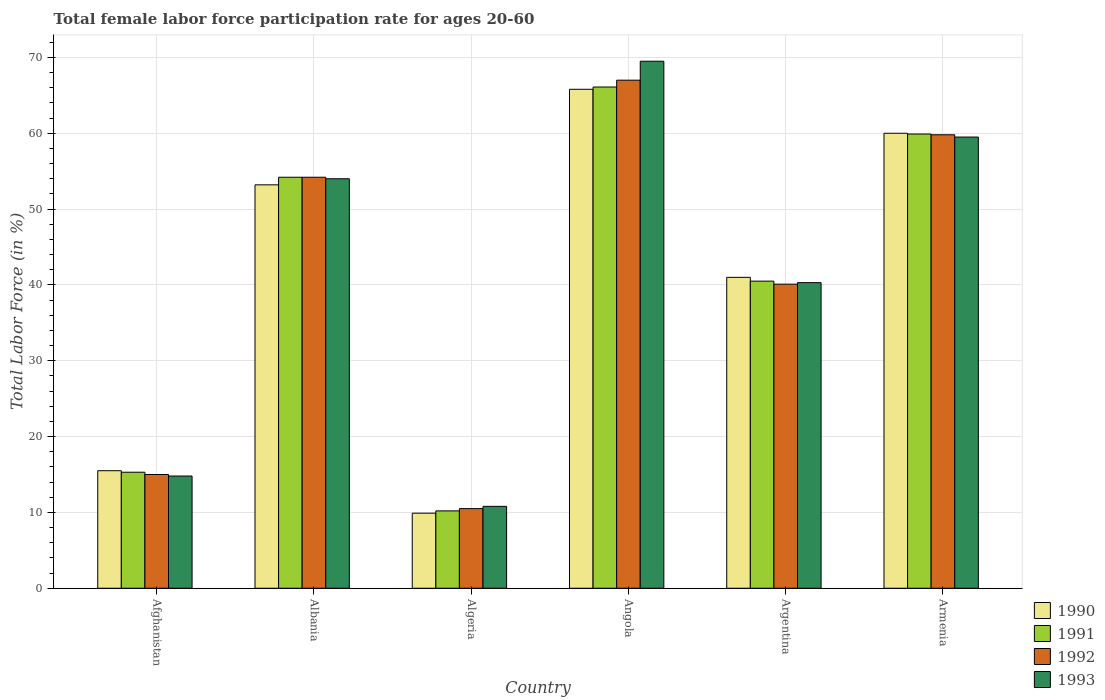How many groups of bars are there?
Your answer should be very brief. 6. How many bars are there on the 2nd tick from the left?
Ensure brevity in your answer.  4. How many bars are there on the 6th tick from the right?
Provide a short and direct response. 4. What is the label of the 4th group of bars from the left?
Keep it short and to the point. Angola. What is the female labor force participation rate in 1992 in Afghanistan?
Offer a very short reply. 15. Across all countries, what is the maximum female labor force participation rate in 1993?
Your answer should be compact. 69.5. Across all countries, what is the minimum female labor force participation rate in 1993?
Offer a very short reply. 10.8. In which country was the female labor force participation rate in 1990 maximum?
Your response must be concise. Angola. In which country was the female labor force participation rate in 1992 minimum?
Make the answer very short. Algeria. What is the total female labor force participation rate in 1990 in the graph?
Ensure brevity in your answer.  245.4. What is the difference between the female labor force participation rate in 1991 in Albania and that in Armenia?
Ensure brevity in your answer.  -5.7. What is the difference between the female labor force participation rate in 1990 in Angola and the female labor force participation rate in 1991 in Albania?
Provide a succinct answer. 11.6. What is the average female labor force participation rate in 1992 per country?
Make the answer very short. 41.1. What is the difference between the female labor force participation rate of/in 1993 and female labor force participation rate of/in 1991 in Albania?
Give a very brief answer. -0.2. In how many countries, is the female labor force participation rate in 1993 greater than 50 %?
Keep it short and to the point. 3. What is the ratio of the female labor force participation rate in 1992 in Albania to that in Armenia?
Offer a terse response. 0.91. Is the difference between the female labor force participation rate in 1993 in Angola and Armenia greater than the difference between the female labor force participation rate in 1991 in Angola and Armenia?
Offer a very short reply. Yes. What is the difference between the highest and the second highest female labor force participation rate in 1991?
Offer a terse response. 6.2. What is the difference between the highest and the lowest female labor force participation rate in 1993?
Your answer should be very brief. 58.7. In how many countries, is the female labor force participation rate in 1992 greater than the average female labor force participation rate in 1992 taken over all countries?
Offer a very short reply. 3. Is the sum of the female labor force participation rate in 1991 in Albania and Argentina greater than the maximum female labor force participation rate in 1990 across all countries?
Your response must be concise. Yes. Is it the case that in every country, the sum of the female labor force participation rate in 1991 and female labor force participation rate in 1992 is greater than the sum of female labor force participation rate in 1993 and female labor force participation rate in 1990?
Offer a terse response. No. What does the 1st bar from the left in Armenia represents?
Provide a short and direct response. 1990. Is it the case that in every country, the sum of the female labor force participation rate in 1991 and female labor force participation rate in 1993 is greater than the female labor force participation rate in 1990?
Your answer should be very brief. Yes. Does the graph contain grids?
Your response must be concise. Yes. Where does the legend appear in the graph?
Offer a very short reply. Bottom right. How many legend labels are there?
Your response must be concise. 4. What is the title of the graph?
Make the answer very short. Total female labor force participation rate for ages 20-60. What is the label or title of the X-axis?
Make the answer very short. Country. What is the Total Labor Force (in %) of 1991 in Afghanistan?
Your answer should be very brief. 15.3. What is the Total Labor Force (in %) in 1992 in Afghanistan?
Ensure brevity in your answer.  15. What is the Total Labor Force (in %) of 1993 in Afghanistan?
Offer a very short reply. 14.8. What is the Total Labor Force (in %) in 1990 in Albania?
Ensure brevity in your answer.  53.2. What is the Total Labor Force (in %) in 1991 in Albania?
Provide a succinct answer. 54.2. What is the Total Labor Force (in %) of 1992 in Albania?
Make the answer very short. 54.2. What is the Total Labor Force (in %) in 1993 in Albania?
Offer a terse response. 54. What is the Total Labor Force (in %) in 1990 in Algeria?
Ensure brevity in your answer.  9.9. What is the Total Labor Force (in %) of 1991 in Algeria?
Offer a terse response. 10.2. What is the Total Labor Force (in %) in 1993 in Algeria?
Your response must be concise. 10.8. What is the Total Labor Force (in %) of 1990 in Angola?
Keep it short and to the point. 65.8. What is the Total Labor Force (in %) of 1991 in Angola?
Offer a very short reply. 66.1. What is the Total Labor Force (in %) of 1993 in Angola?
Offer a very short reply. 69.5. What is the Total Labor Force (in %) of 1990 in Argentina?
Keep it short and to the point. 41. What is the Total Labor Force (in %) of 1991 in Argentina?
Give a very brief answer. 40.5. What is the Total Labor Force (in %) in 1992 in Argentina?
Offer a terse response. 40.1. What is the Total Labor Force (in %) of 1993 in Argentina?
Make the answer very short. 40.3. What is the Total Labor Force (in %) of 1991 in Armenia?
Give a very brief answer. 59.9. What is the Total Labor Force (in %) in 1992 in Armenia?
Provide a succinct answer. 59.8. What is the Total Labor Force (in %) in 1993 in Armenia?
Provide a short and direct response. 59.5. Across all countries, what is the maximum Total Labor Force (in %) in 1990?
Your response must be concise. 65.8. Across all countries, what is the maximum Total Labor Force (in %) of 1991?
Give a very brief answer. 66.1. Across all countries, what is the maximum Total Labor Force (in %) of 1992?
Provide a succinct answer. 67. Across all countries, what is the maximum Total Labor Force (in %) of 1993?
Your answer should be very brief. 69.5. Across all countries, what is the minimum Total Labor Force (in %) in 1990?
Keep it short and to the point. 9.9. Across all countries, what is the minimum Total Labor Force (in %) in 1991?
Your answer should be compact. 10.2. Across all countries, what is the minimum Total Labor Force (in %) in 1992?
Give a very brief answer. 10.5. Across all countries, what is the minimum Total Labor Force (in %) in 1993?
Give a very brief answer. 10.8. What is the total Total Labor Force (in %) in 1990 in the graph?
Give a very brief answer. 245.4. What is the total Total Labor Force (in %) in 1991 in the graph?
Make the answer very short. 246.2. What is the total Total Labor Force (in %) of 1992 in the graph?
Make the answer very short. 246.6. What is the total Total Labor Force (in %) of 1993 in the graph?
Keep it short and to the point. 248.9. What is the difference between the Total Labor Force (in %) in 1990 in Afghanistan and that in Albania?
Offer a terse response. -37.7. What is the difference between the Total Labor Force (in %) in 1991 in Afghanistan and that in Albania?
Your response must be concise. -38.9. What is the difference between the Total Labor Force (in %) in 1992 in Afghanistan and that in Albania?
Keep it short and to the point. -39.2. What is the difference between the Total Labor Force (in %) of 1993 in Afghanistan and that in Albania?
Offer a terse response. -39.2. What is the difference between the Total Labor Force (in %) in 1991 in Afghanistan and that in Algeria?
Offer a terse response. 5.1. What is the difference between the Total Labor Force (in %) in 1992 in Afghanistan and that in Algeria?
Keep it short and to the point. 4.5. What is the difference between the Total Labor Force (in %) in 1990 in Afghanistan and that in Angola?
Provide a succinct answer. -50.3. What is the difference between the Total Labor Force (in %) in 1991 in Afghanistan and that in Angola?
Offer a very short reply. -50.8. What is the difference between the Total Labor Force (in %) of 1992 in Afghanistan and that in Angola?
Your answer should be very brief. -52. What is the difference between the Total Labor Force (in %) of 1993 in Afghanistan and that in Angola?
Give a very brief answer. -54.7. What is the difference between the Total Labor Force (in %) of 1990 in Afghanistan and that in Argentina?
Provide a succinct answer. -25.5. What is the difference between the Total Labor Force (in %) of 1991 in Afghanistan and that in Argentina?
Offer a very short reply. -25.2. What is the difference between the Total Labor Force (in %) of 1992 in Afghanistan and that in Argentina?
Give a very brief answer. -25.1. What is the difference between the Total Labor Force (in %) of 1993 in Afghanistan and that in Argentina?
Offer a very short reply. -25.5. What is the difference between the Total Labor Force (in %) of 1990 in Afghanistan and that in Armenia?
Keep it short and to the point. -44.5. What is the difference between the Total Labor Force (in %) of 1991 in Afghanistan and that in Armenia?
Make the answer very short. -44.6. What is the difference between the Total Labor Force (in %) in 1992 in Afghanistan and that in Armenia?
Give a very brief answer. -44.8. What is the difference between the Total Labor Force (in %) in 1993 in Afghanistan and that in Armenia?
Your answer should be compact. -44.7. What is the difference between the Total Labor Force (in %) of 1990 in Albania and that in Algeria?
Provide a succinct answer. 43.3. What is the difference between the Total Labor Force (in %) in 1991 in Albania and that in Algeria?
Offer a very short reply. 44. What is the difference between the Total Labor Force (in %) in 1992 in Albania and that in Algeria?
Give a very brief answer. 43.7. What is the difference between the Total Labor Force (in %) of 1993 in Albania and that in Algeria?
Offer a very short reply. 43.2. What is the difference between the Total Labor Force (in %) in 1993 in Albania and that in Angola?
Offer a terse response. -15.5. What is the difference between the Total Labor Force (in %) in 1992 in Albania and that in Argentina?
Your answer should be very brief. 14.1. What is the difference between the Total Labor Force (in %) in 1993 in Albania and that in Argentina?
Your answer should be very brief. 13.7. What is the difference between the Total Labor Force (in %) of 1990 in Albania and that in Armenia?
Offer a very short reply. -6.8. What is the difference between the Total Labor Force (in %) in 1992 in Albania and that in Armenia?
Provide a short and direct response. -5.6. What is the difference between the Total Labor Force (in %) in 1993 in Albania and that in Armenia?
Offer a very short reply. -5.5. What is the difference between the Total Labor Force (in %) in 1990 in Algeria and that in Angola?
Offer a terse response. -55.9. What is the difference between the Total Labor Force (in %) of 1991 in Algeria and that in Angola?
Keep it short and to the point. -55.9. What is the difference between the Total Labor Force (in %) of 1992 in Algeria and that in Angola?
Your answer should be very brief. -56.5. What is the difference between the Total Labor Force (in %) in 1993 in Algeria and that in Angola?
Provide a succinct answer. -58.7. What is the difference between the Total Labor Force (in %) in 1990 in Algeria and that in Argentina?
Offer a terse response. -31.1. What is the difference between the Total Labor Force (in %) of 1991 in Algeria and that in Argentina?
Give a very brief answer. -30.3. What is the difference between the Total Labor Force (in %) in 1992 in Algeria and that in Argentina?
Offer a terse response. -29.6. What is the difference between the Total Labor Force (in %) in 1993 in Algeria and that in Argentina?
Offer a very short reply. -29.5. What is the difference between the Total Labor Force (in %) in 1990 in Algeria and that in Armenia?
Your answer should be compact. -50.1. What is the difference between the Total Labor Force (in %) of 1991 in Algeria and that in Armenia?
Your answer should be very brief. -49.7. What is the difference between the Total Labor Force (in %) in 1992 in Algeria and that in Armenia?
Give a very brief answer. -49.3. What is the difference between the Total Labor Force (in %) in 1993 in Algeria and that in Armenia?
Offer a terse response. -48.7. What is the difference between the Total Labor Force (in %) in 1990 in Angola and that in Argentina?
Offer a terse response. 24.8. What is the difference between the Total Labor Force (in %) in 1991 in Angola and that in Argentina?
Your answer should be compact. 25.6. What is the difference between the Total Labor Force (in %) of 1992 in Angola and that in Argentina?
Keep it short and to the point. 26.9. What is the difference between the Total Labor Force (in %) of 1993 in Angola and that in Argentina?
Offer a very short reply. 29.2. What is the difference between the Total Labor Force (in %) in 1993 in Angola and that in Armenia?
Your answer should be compact. 10. What is the difference between the Total Labor Force (in %) in 1990 in Argentina and that in Armenia?
Make the answer very short. -19. What is the difference between the Total Labor Force (in %) in 1991 in Argentina and that in Armenia?
Keep it short and to the point. -19.4. What is the difference between the Total Labor Force (in %) of 1992 in Argentina and that in Armenia?
Your response must be concise. -19.7. What is the difference between the Total Labor Force (in %) in 1993 in Argentina and that in Armenia?
Your answer should be compact. -19.2. What is the difference between the Total Labor Force (in %) in 1990 in Afghanistan and the Total Labor Force (in %) in 1991 in Albania?
Give a very brief answer. -38.7. What is the difference between the Total Labor Force (in %) of 1990 in Afghanistan and the Total Labor Force (in %) of 1992 in Albania?
Provide a succinct answer. -38.7. What is the difference between the Total Labor Force (in %) in 1990 in Afghanistan and the Total Labor Force (in %) in 1993 in Albania?
Your answer should be very brief. -38.5. What is the difference between the Total Labor Force (in %) in 1991 in Afghanistan and the Total Labor Force (in %) in 1992 in Albania?
Offer a very short reply. -38.9. What is the difference between the Total Labor Force (in %) of 1991 in Afghanistan and the Total Labor Force (in %) of 1993 in Albania?
Keep it short and to the point. -38.7. What is the difference between the Total Labor Force (in %) in 1992 in Afghanistan and the Total Labor Force (in %) in 1993 in Albania?
Give a very brief answer. -39. What is the difference between the Total Labor Force (in %) of 1990 in Afghanistan and the Total Labor Force (in %) of 1993 in Algeria?
Offer a terse response. 4.7. What is the difference between the Total Labor Force (in %) of 1991 in Afghanistan and the Total Labor Force (in %) of 1993 in Algeria?
Your answer should be compact. 4.5. What is the difference between the Total Labor Force (in %) in 1992 in Afghanistan and the Total Labor Force (in %) in 1993 in Algeria?
Keep it short and to the point. 4.2. What is the difference between the Total Labor Force (in %) of 1990 in Afghanistan and the Total Labor Force (in %) of 1991 in Angola?
Provide a succinct answer. -50.6. What is the difference between the Total Labor Force (in %) of 1990 in Afghanistan and the Total Labor Force (in %) of 1992 in Angola?
Ensure brevity in your answer.  -51.5. What is the difference between the Total Labor Force (in %) in 1990 in Afghanistan and the Total Labor Force (in %) in 1993 in Angola?
Your response must be concise. -54. What is the difference between the Total Labor Force (in %) of 1991 in Afghanistan and the Total Labor Force (in %) of 1992 in Angola?
Your answer should be very brief. -51.7. What is the difference between the Total Labor Force (in %) of 1991 in Afghanistan and the Total Labor Force (in %) of 1993 in Angola?
Provide a short and direct response. -54.2. What is the difference between the Total Labor Force (in %) of 1992 in Afghanistan and the Total Labor Force (in %) of 1993 in Angola?
Provide a short and direct response. -54.5. What is the difference between the Total Labor Force (in %) in 1990 in Afghanistan and the Total Labor Force (in %) in 1992 in Argentina?
Give a very brief answer. -24.6. What is the difference between the Total Labor Force (in %) of 1990 in Afghanistan and the Total Labor Force (in %) of 1993 in Argentina?
Your response must be concise. -24.8. What is the difference between the Total Labor Force (in %) in 1991 in Afghanistan and the Total Labor Force (in %) in 1992 in Argentina?
Give a very brief answer. -24.8. What is the difference between the Total Labor Force (in %) of 1992 in Afghanistan and the Total Labor Force (in %) of 1993 in Argentina?
Ensure brevity in your answer.  -25.3. What is the difference between the Total Labor Force (in %) in 1990 in Afghanistan and the Total Labor Force (in %) in 1991 in Armenia?
Offer a terse response. -44.4. What is the difference between the Total Labor Force (in %) in 1990 in Afghanistan and the Total Labor Force (in %) in 1992 in Armenia?
Provide a succinct answer. -44.3. What is the difference between the Total Labor Force (in %) in 1990 in Afghanistan and the Total Labor Force (in %) in 1993 in Armenia?
Keep it short and to the point. -44. What is the difference between the Total Labor Force (in %) of 1991 in Afghanistan and the Total Labor Force (in %) of 1992 in Armenia?
Provide a succinct answer. -44.5. What is the difference between the Total Labor Force (in %) in 1991 in Afghanistan and the Total Labor Force (in %) in 1993 in Armenia?
Ensure brevity in your answer.  -44.2. What is the difference between the Total Labor Force (in %) in 1992 in Afghanistan and the Total Labor Force (in %) in 1993 in Armenia?
Ensure brevity in your answer.  -44.5. What is the difference between the Total Labor Force (in %) of 1990 in Albania and the Total Labor Force (in %) of 1991 in Algeria?
Keep it short and to the point. 43. What is the difference between the Total Labor Force (in %) in 1990 in Albania and the Total Labor Force (in %) in 1992 in Algeria?
Your response must be concise. 42.7. What is the difference between the Total Labor Force (in %) of 1990 in Albania and the Total Labor Force (in %) of 1993 in Algeria?
Your answer should be compact. 42.4. What is the difference between the Total Labor Force (in %) in 1991 in Albania and the Total Labor Force (in %) in 1992 in Algeria?
Offer a terse response. 43.7. What is the difference between the Total Labor Force (in %) of 1991 in Albania and the Total Labor Force (in %) of 1993 in Algeria?
Give a very brief answer. 43.4. What is the difference between the Total Labor Force (in %) in 1992 in Albania and the Total Labor Force (in %) in 1993 in Algeria?
Offer a terse response. 43.4. What is the difference between the Total Labor Force (in %) of 1990 in Albania and the Total Labor Force (in %) of 1991 in Angola?
Your answer should be very brief. -12.9. What is the difference between the Total Labor Force (in %) in 1990 in Albania and the Total Labor Force (in %) in 1993 in Angola?
Give a very brief answer. -16.3. What is the difference between the Total Labor Force (in %) in 1991 in Albania and the Total Labor Force (in %) in 1992 in Angola?
Your response must be concise. -12.8. What is the difference between the Total Labor Force (in %) of 1991 in Albania and the Total Labor Force (in %) of 1993 in Angola?
Provide a short and direct response. -15.3. What is the difference between the Total Labor Force (in %) in 1992 in Albania and the Total Labor Force (in %) in 1993 in Angola?
Offer a terse response. -15.3. What is the difference between the Total Labor Force (in %) in 1990 in Albania and the Total Labor Force (in %) in 1992 in Argentina?
Make the answer very short. 13.1. What is the difference between the Total Labor Force (in %) of 1990 in Albania and the Total Labor Force (in %) of 1993 in Argentina?
Provide a short and direct response. 12.9. What is the difference between the Total Labor Force (in %) of 1991 in Albania and the Total Labor Force (in %) of 1992 in Argentina?
Your response must be concise. 14.1. What is the difference between the Total Labor Force (in %) in 1991 in Albania and the Total Labor Force (in %) in 1992 in Armenia?
Your answer should be very brief. -5.6. What is the difference between the Total Labor Force (in %) in 1991 in Albania and the Total Labor Force (in %) in 1993 in Armenia?
Offer a very short reply. -5.3. What is the difference between the Total Labor Force (in %) of 1990 in Algeria and the Total Labor Force (in %) of 1991 in Angola?
Your response must be concise. -56.2. What is the difference between the Total Labor Force (in %) of 1990 in Algeria and the Total Labor Force (in %) of 1992 in Angola?
Make the answer very short. -57.1. What is the difference between the Total Labor Force (in %) of 1990 in Algeria and the Total Labor Force (in %) of 1993 in Angola?
Your answer should be compact. -59.6. What is the difference between the Total Labor Force (in %) of 1991 in Algeria and the Total Labor Force (in %) of 1992 in Angola?
Ensure brevity in your answer.  -56.8. What is the difference between the Total Labor Force (in %) in 1991 in Algeria and the Total Labor Force (in %) in 1993 in Angola?
Give a very brief answer. -59.3. What is the difference between the Total Labor Force (in %) of 1992 in Algeria and the Total Labor Force (in %) of 1993 in Angola?
Provide a succinct answer. -59. What is the difference between the Total Labor Force (in %) in 1990 in Algeria and the Total Labor Force (in %) in 1991 in Argentina?
Provide a short and direct response. -30.6. What is the difference between the Total Labor Force (in %) in 1990 in Algeria and the Total Labor Force (in %) in 1992 in Argentina?
Provide a succinct answer. -30.2. What is the difference between the Total Labor Force (in %) in 1990 in Algeria and the Total Labor Force (in %) in 1993 in Argentina?
Provide a short and direct response. -30.4. What is the difference between the Total Labor Force (in %) of 1991 in Algeria and the Total Labor Force (in %) of 1992 in Argentina?
Your answer should be compact. -29.9. What is the difference between the Total Labor Force (in %) of 1991 in Algeria and the Total Labor Force (in %) of 1993 in Argentina?
Make the answer very short. -30.1. What is the difference between the Total Labor Force (in %) of 1992 in Algeria and the Total Labor Force (in %) of 1993 in Argentina?
Ensure brevity in your answer.  -29.8. What is the difference between the Total Labor Force (in %) of 1990 in Algeria and the Total Labor Force (in %) of 1991 in Armenia?
Your answer should be compact. -50. What is the difference between the Total Labor Force (in %) in 1990 in Algeria and the Total Labor Force (in %) in 1992 in Armenia?
Ensure brevity in your answer.  -49.9. What is the difference between the Total Labor Force (in %) in 1990 in Algeria and the Total Labor Force (in %) in 1993 in Armenia?
Give a very brief answer. -49.6. What is the difference between the Total Labor Force (in %) in 1991 in Algeria and the Total Labor Force (in %) in 1992 in Armenia?
Offer a very short reply. -49.6. What is the difference between the Total Labor Force (in %) of 1991 in Algeria and the Total Labor Force (in %) of 1993 in Armenia?
Your answer should be compact. -49.3. What is the difference between the Total Labor Force (in %) of 1992 in Algeria and the Total Labor Force (in %) of 1993 in Armenia?
Offer a very short reply. -49. What is the difference between the Total Labor Force (in %) in 1990 in Angola and the Total Labor Force (in %) in 1991 in Argentina?
Your answer should be very brief. 25.3. What is the difference between the Total Labor Force (in %) in 1990 in Angola and the Total Labor Force (in %) in 1992 in Argentina?
Ensure brevity in your answer.  25.7. What is the difference between the Total Labor Force (in %) in 1990 in Angola and the Total Labor Force (in %) in 1993 in Argentina?
Offer a terse response. 25.5. What is the difference between the Total Labor Force (in %) of 1991 in Angola and the Total Labor Force (in %) of 1993 in Argentina?
Your answer should be very brief. 25.8. What is the difference between the Total Labor Force (in %) of 1992 in Angola and the Total Labor Force (in %) of 1993 in Argentina?
Make the answer very short. 26.7. What is the difference between the Total Labor Force (in %) in 1990 in Angola and the Total Labor Force (in %) in 1991 in Armenia?
Keep it short and to the point. 5.9. What is the difference between the Total Labor Force (in %) of 1990 in Angola and the Total Labor Force (in %) of 1992 in Armenia?
Offer a terse response. 6. What is the difference between the Total Labor Force (in %) of 1991 in Angola and the Total Labor Force (in %) of 1992 in Armenia?
Give a very brief answer. 6.3. What is the difference between the Total Labor Force (in %) of 1991 in Angola and the Total Labor Force (in %) of 1993 in Armenia?
Make the answer very short. 6.6. What is the difference between the Total Labor Force (in %) of 1990 in Argentina and the Total Labor Force (in %) of 1991 in Armenia?
Offer a very short reply. -18.9. What is the difference between the Total Labor Force (in %) in 1990 in Argentina and the Total Labor Force (in %) in 1992 in Armenia?
Provide a short and direct response. -18.8. What is the difference between the Total Labor Force (in %) of 1990 in Argentina and the Total Labor Force (in %) of 1993 in Armenia?
Offer a terse response. -18.5. What is the difference between the Total Labor Force (in %) of 1991 in Argentina and the Total Labor Force (in %) of 1992 in Armenia?
Your answer should be compact. -19.3. What is the difference between the Total Labor Force (in %) of 1992 in Argentina and the Total Labor Force (in %) of 1993 in Armenia?
Provide a succinct answer. -19.4. What is the average Total Labor Force (in %) of 1990 per country?
Provide a short and direct response. 40.9. What is the average Total Labor Force (in %) of 1991 per country?
Your response must be concise. 41.03. What is the average Total Labor Force (in %) in 1992 per country?
Offer a terse response. 41.1. What is the average Total Labor Force (in %) of 1993 per country?
Give a very brief answer. 41.48. What is the difference between the Total Labor Force (in %) of 1990 and Total Labor Force (in %) of 1991 in Afghanistan?
Your answer should be very brief. 0.2. What is the difference between the Total Labor Force (in %) of 1992 and Total Labor Force (in %) of 1993 in Afghanistan?
Offer a very short reply. 0.2. What is the difference between the Total Labor Force (in %) in 1990 and Total Labor Force (in %) in 1991 in Albania?
Give a very brief answer. -1. What is the difference between the Total Labor Force (in %) in 1990 and Total Labor Force (in %) in 1992 in Albania?
Provide a succinct answer. -1. What is the difference between the Total Labor Force (in %) in 1990 and Total Labor Force (in %) in 1993 in Albania?
Ensure brevity in your answer.  -0.8. What is the difference between the Total Labor Force (in %) of 1991 and Total Labor Force (in %) of 1992 in Albania?
Your answer should be very brief. 0. What is the difference between the Total Labor Force (in %) of 1990 and Total Labor Force (in %) of 1993 in Algeria?
Ensure brevity in your answer.  -0.9. What is the difference between the Total Labor Force (in %) of 1991 and Total Labor Force (in %) of 1992 in Algeria?
Offer a very short reply. -0.3. What is the difference between the Total Labor Force (in %) of 1991 and Total Labor Force (in %) of 1993 in Algeria?
Offer a very short reply. -0.6. What is the difference between the Total Labor Force (in %) of 1992 and Total Labor Force (in %) of 1993 in Algeria?
Offer a very short reply. -0.3. What is the difference between the Total Labor Force (in %) in 1990 and Total Labor Force (in %) in 1991 in Angola?
Ensure brevity in your answer.  -0.3. What is the difference between the Total Labor Force (in %) in 1991 and Total Labor Force (in %) in 1993 in Angola?
Your response must be concise. -3.4. What is the difference between the Total Labor Force (in %) in 1990 and Total Labor Force (in %) in 1991 in Argentina?
Ensure brevity in your answer.  0.5. What is the difference between the Total Labor Force (in %) of 1990 and Total Labor Force (in %) of 1992 in Argentina?
Make the answer very short. 0.9. What is the difference between the Total Labor Force (in %) of 1990 and Total Labor Force (in %) of 1993 in Argentina?
Your response must be concise. 0.7. What is the difference between the Total Labor Force (in %) of 1991 and Total Labor Force (in %) of 1992 in Argentina?
Ensure brevity in your answer.  0.4. What is the difference between the Total Labor Force (in %) of 1991 and Total Labor Force (in %) of 1993 in Argentina?
Provide a short and direct response. 0.2. What is the difference between the Total Labor Force (in %) in 1990 and Total Labor Force (in %) in 1992 in Armenia?
Provide a succinct answer. 0.2. What is the difference between the Total Labor Force (in %) in 1991 and Total Labor Force (in %) in 1992 in Armenia?
Offer a very short reply. 0.1. What is the difference between the Total Labor Force (in %) of 1991 and Total Labor Force (in %) of 1993 in Armenia?
Offer a very short reply. 0.4. What is the ratio of the Total Labor Force (in %) of 1990 in Afghanistan to that in Albania?
Give a very brief answer. 0.29. What is the ratio of the Total Labor Force (in %) of 1991 in Afghanistan to that in Albania?
Your answer should be compact. 0.28. What is the ratio of the Total Labor Force (in %) of 1992 in Afghanistan to that in Albania?
Provide a succinct answer. 0.28. What is the ratio of the Total Labor Force (in %) in 1993 in Afghanistan to that in Albania?
Your answer should be compact. 0.27. What is the ratio of the Total Labor Force (in %) of 1990 in Afghanistan to that in Algeria?
Give a very brief answer. 1.57. What is the ratio of the Total Labor Force (in %) of 1992 in Afghanistan to that in Algeria?
Offer a very short reply. 1.43. What is the ratio of the Total Labor Force (in %) in 1993 in Afghanistan to that in Algeria?
Keep it short and to the point. 1.37. What is the ratio of the Total Labor Force (in %) of 1990 in Afghanistan to that in Angola?
Make the answer very short. 0.24. What is the ratio of the Total Labor Force (in %) in 1991 in Afghanistan to that in Angola?
Keep it short and to the point. 0.23. What is the ratio of the Total Labor Force (in %) in 1992 in Afghanistan to that in Angola?
Ensure brevity in your answer.  0.22. What is the ratio of the Total Labor Force (in %) of 1993 in Afghanistan to that in Angola?
Provide a short and direct response. 0.21. What is the ratio of the Total Labor Force (in %) in 1990 in Afghanistan to that in Argentina?
Offer a terse response. 0.38. What is the ratio of the Total Labor Force (in %) in 1991 in Afghanistan to that in Argentina?
Ensure brevity in your answer.  0.38. What is the ratio of the Total Labor Force (in %) in 1992 in Afghanistan to that in Argentina?
Your answer should be very brief. 0.37. What is the ratio of the Total Labor Force (in %) of 1993 in Afghanistan to that in Argentina?
Make the answer very short. 0.37. What is the ratio of the Total Labor Force (in %) of 1990 in Afghanistan to that in Armenia?
Give a very brief answer. 0.26. What is the ratio of the Total Labor Force (in %) of 1991 in Afghanistan to that in Armenia?
Offer a very short reply. 0.26. What is the ratio of the Total Labor Force (in %) in 1992 in Afghanistan to that in Armenia?
Keep it short and to the point. 0.25. What is the ratio of the Total Labor Force (in %) of 1993 in Afghanistan to that in Armenia?
Your answer should be compact. 0.25. What is the ratio of the Total Labor Force (in %) of 1990 in Albania to that in Algeria?
Provide a short and direct response. 5.37. What is the ratio of the Total Labor Force (in %) of 1991 in Albania to that in Algeria?
Your response must be concise. 5.31. What is the ratio of the Total Labor Force (in %) of 1992 in Albania to that in Algeria?
Your answer should be very brief. 5.16. What is the ratio of the Total Labor Force (in %) of 1993 in Albania to that in Algeria?
Keep it short and to the point. 5. What is the ratio of the Total Labor Force (in %) of 1990 in Albania to that in Angola?
Make the answer very short. 0.81. What is the ratio of the Total Labor Force (in %) of 1991 in Albania to that in Angola?
Give a very brief answer. 0.82. What is the ratio of the Total Labor Force (in %) of 1992 in Albania to that in Angola?
Ensure brevity in your answer.  0.81. What is the ratio of the Total Labor Force (in %) of 1993 in Albania to that in Angola?
Offer a very short reply. 0.78. What is the ratio of the Total Labor Force (in %) of 1990 in Albania to that in Argentina?
Give a very brief answer. 1.3. What is the ratio of the Total Labor Force (in %) of 1991 in Albania to that in Argentina?
Provide a succinct answer. 1.34. What is the ratio of the Total Labor Force (in %) of 1992 in Albania to that in Argentina?
Give a very brief answer. 1.35. What is the ratio of the Total Labor Force (in %) of 1993 in Albania to that in Argentina?
Your answer should be compact. 1.34. What is the ratio of the Total Labor Force (in %) of 1990 in Albania to that in Armenia?
Keep it short and to the point. 0.89. What is the ratio of the Total Labor Force (in %) in 1991 in Albania to that in Armenia?
Ensure brevity in your answer.  0.9. What is the ratio of the Total Labor Force (in %) of 1992 in Albania to that in Armenia?
Give a very brief answer. 0.91. What is the ratio of the Total Labor Force (in %) of 1993 in Albania to that in Armenia?
Provide a succinct answer. 0.91. What is the ratio of the Total Labor Force (in %) of 1990 in Algeria to that in Angola?
Your answer should be very brief. 0.15. What is the ratio of the Total Labor Force (in %) in 1991 in Algeria to that in Angola?
Offer a terse response. 0.15. What is the ratio of the Total Labor Force (in %) of 1992 in Algeria to that in Angola?
Provide a short and direct response. 0.16. What is the ratio of the Total Labor Force (in %) in 1993 in Algeria to that in Angola?
Provide a short and direct response. 0.16. What is the ratio of the Total Labor Force (in %) of 1990 in Algeria to that in Argentina?
Make the answer very short. 0.24. What is the ratio of the Total Labor Force (in %) of 1991 in Algeria to that in Argentina?
Keep it short and to the point. 0.25. What is the ratio of the Total Labor Force (in %) in 1992 in Algeria to that in Argentina?
Your answer should be very brief. 0.26. What is the ratio of the Total Labor Force (in %) of 1993 in Algeria to that in Argentina?
Your response must be concise. 0.27. What is the ratio of the Total Labor Force (in %) of 1990 in Algeria to that in Armenia?
Provide a succinct answer. 0.17. What is the ratio of the Total Labor Force (in %) of 1991 in Algeria to that in Armenia?
Offer a terse response. 0.17. What is the ratio of the Total Labor Force (in %) of 1992 in Algeria to that in Armenia?
Your response must be concise. 0.18. What is the ratio of the Total Labor Force (in %) in 1993 in Algeria to that in Armenia?
Your response must be concise. 0.18. What is the ratio of the Total Labor Force (in %) of 1990 in Angola to that in Argentina?
Give a very brief answer. 1.6. What is the ratio of the Total Labor Force (in %) of 1991 in Angola to that in Argentina?
Your response must be concise. 1.63. What is the ratio of the Total Labor Force (in %) in 1992 in Angola to that in Argentina?
Offer a terse response. 1.67. What is the ratio of the Total Labor Force (in %) in 1993 in Angola to that in Argentina?
Your answer should be compact. 1.72. What is the ratio of the Total Labor Force (in %) of 1990 in Angola to that in Armenia?
Your answer should be very brief. 1.1. What is the ratio of the Total Labor Force (in %) in 1991 in Angola to that in Armenia?
Your answer should be compact. 1.1. What is the ratio of the Total Labor Force (in %) of 1992 in Angola to that in Armenia?
Your answer should be compact. 1.12. What is the ratio of the Total Labor Force (in %) in 1993 in Angola to that in Armenia?
Offer a terse response. 1.17. What is the ratio of the Total Labor Force (in %) in 1990 in Argentina to that in Armenia?
Provide a succinct answer. 0.68. What is the ratio of the Total Labor Force (in %) of 1991 in Argentina to that in Armenia?
Offer a very short reply. 0.68. What is the ratio of the Total Labor Force (in %) of 1992 in Argentina to that in Armenia?
Your answer should be compact. 0.67. What is the ratio of the Total Labor Force (in %) in 1993 in Argentina to that in Armenia?
Your answer should be very brief. 0.68. What is the difference between the highest and the second highest Total Labor Force (in %) in 1990?
Your response must be concise. 5.8. What is the difference between the highest and the second highest Total Labor Force (in %) in 1991?
Your answer should be very brief. 6.2. What is the difference between the highest and the second highest Total Labor Force (in %) of 1993?
Your answer should be compact. 10. What is the difference between the highest and the lowest Total Labor Force (in %) of 1990?
Your response must be concise. 55.9. What is the difference between the highest and the lowest Total Labor Force (in %) of 1991?
Your answer should be compact. 55.9. What is the difference between the highest and the lowest Total Labor Force (in %) of 1992?
Your answer should be compact. 56.5. What is the difference between the highest and the lowest Total Labor Force (in %) of 1993?
Give a very brief answer. 58.7. 